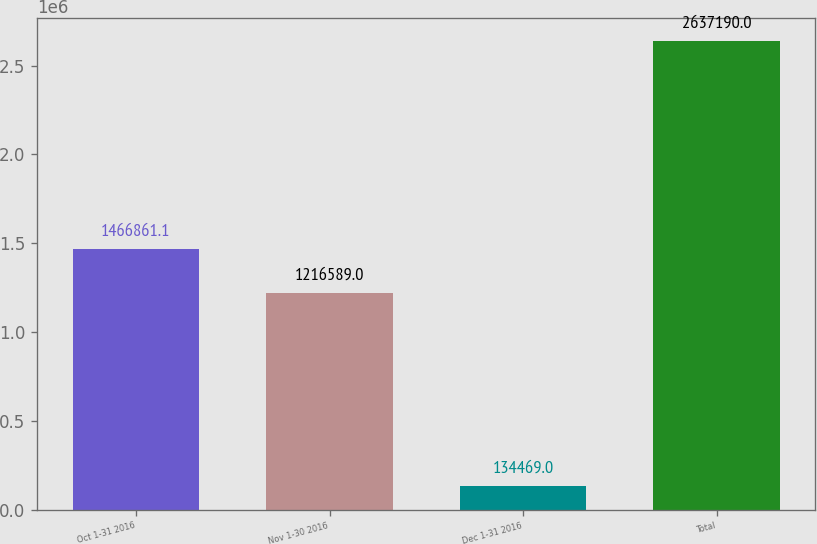<chart> <loc_0><loc_0><loc_500><loc_500><bar_chart><fcel>Oct 1-31 2016<fcel>Nov 1-30 2016<fcel>Dec 1-31 2016<fcel>Total<nl><fcel>1.46686e+06<fcel>1.21659e+06<fcel>134469<fcel>2.63719e+06<nl></chart> 